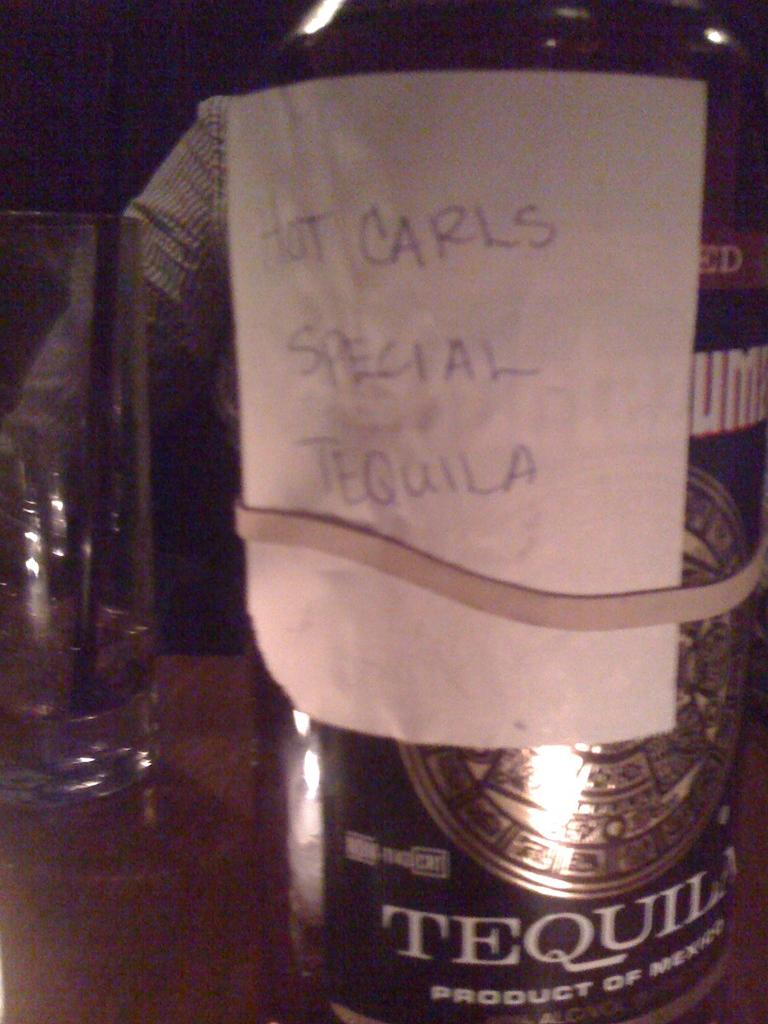<image>
Give a short and clear explanation of the subsequent image. a special tequila that is written on some paper 